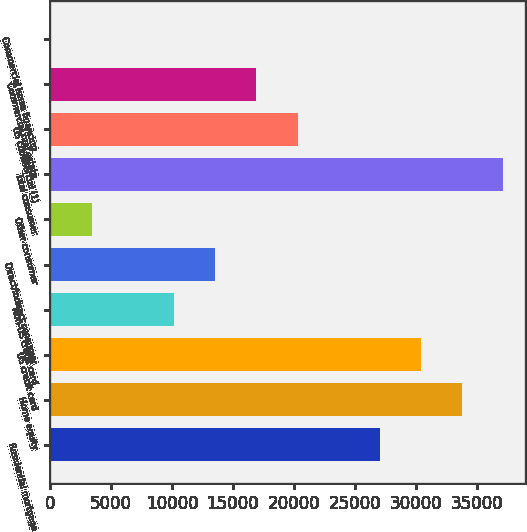Convert chart. <chart><loc_0><loc_0><loc_500><loc_500><bar_chart><fcel>Residential mortgage<fcel>Home equity<fcel>US credit card<fcel>Non-US credit card<fcel>Direct/Indirect consumer<fcel>Other consumer<fcel>Total consumer<fcel>US commercial (1)<fcel>Commercial real estate<fcel>Commercial lease financing<nl><fcel>27044.8<fcel>33783<fcel>30413.9<fcel>10199.3<fcel>13568.4<fcel>3461.1<fcel>37152.1<fcel>20306.6<fcel>16937.5<fcel>92<nl></chart> 